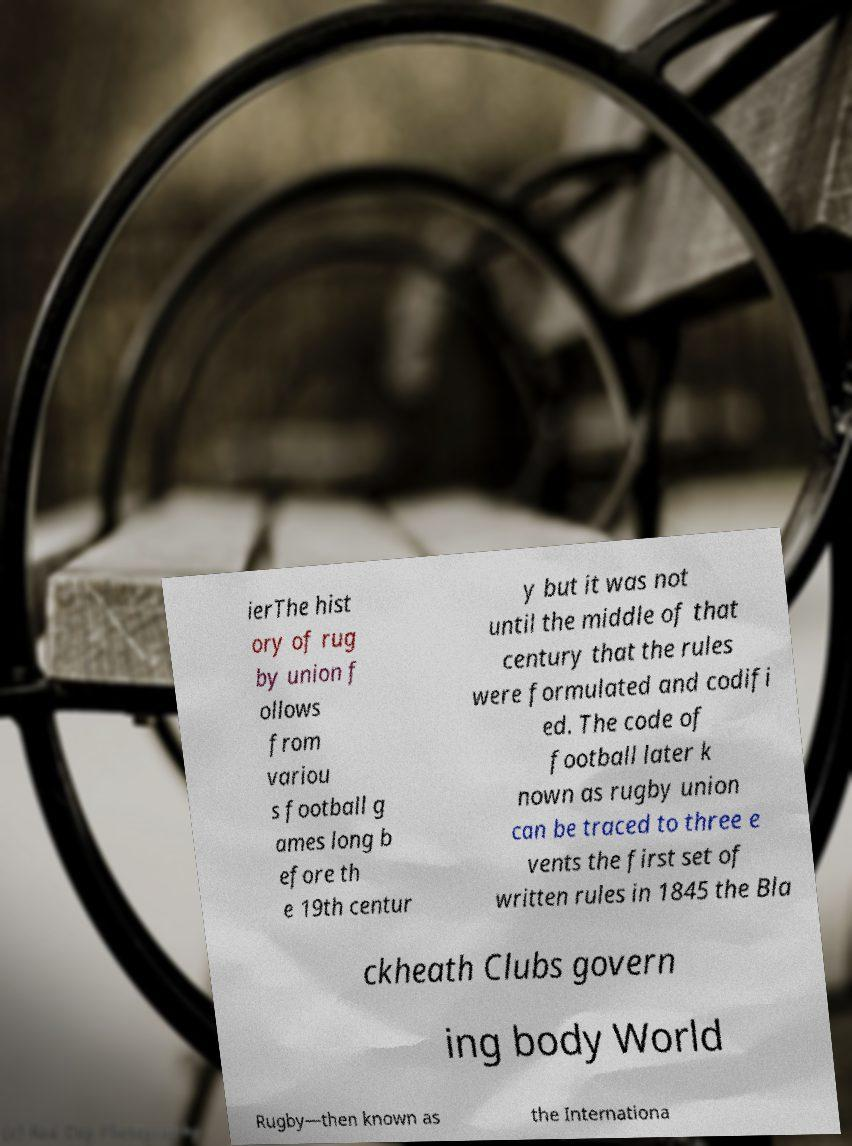Could you extract and type out the text from this image? ierThe hist ory of rug by union f ollows from variou s football g ames long b efore th e 19th centur y but it was not until the middle of that century that the rules were formulated and codifi ed. The code of football later k nown as rugby union can be traced to three e vents the first set of written rules in 1845 the Bla ckheath Clubs govern ing body World Rugby—then known as the Internationa 